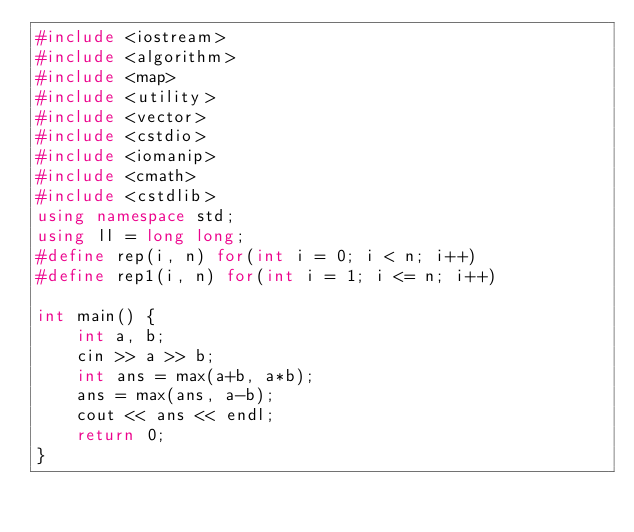Convert code to text. <code><loc_0><loc_0><loc_500><loc_500><_C++_>#include <iostream>
#include <algorithm>
#include <map>
#include <utility>
#include <vector>
#include <cstdio>
#include <iomanip>
#include <cmath>
#include <cstdlib>
using namespace std;
using ll = long long;
#define rep(i, n) for(int i = 0; i < n; i++)
#define rep1(i, n) for(int i = 1; i <= n; i++) 

int main() {
    int a, b;
    cin >> a >> b;
    int ans = max(a+b, a*b);
    ans = max(ans, a-b);
    cout << ans << endl;
    return 0;
}</code> 